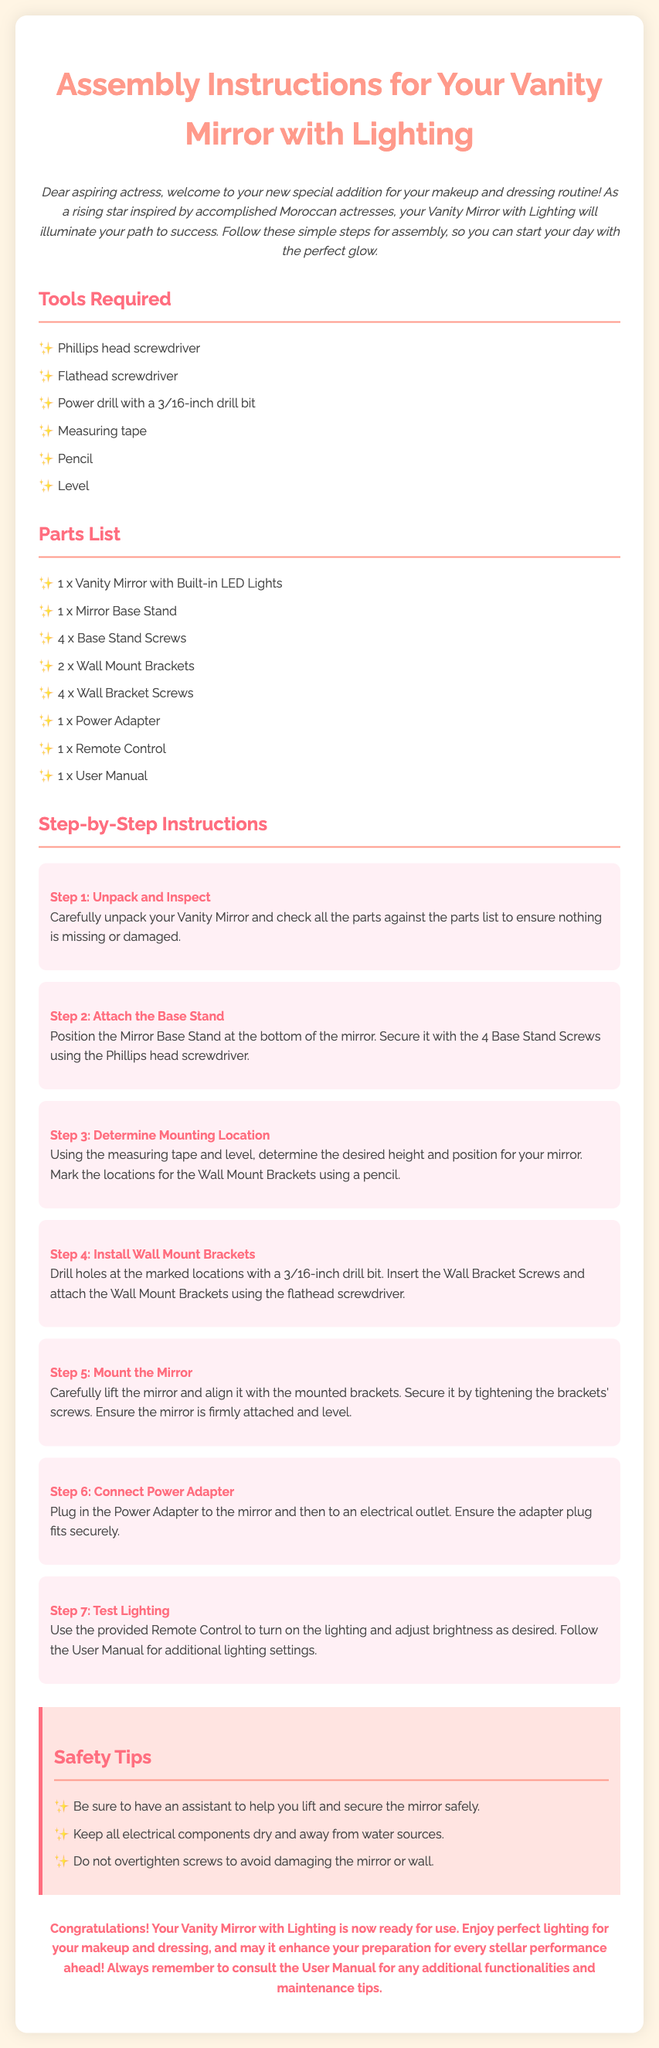What tools are required? The document lists the tools needed for assembly, which include a Phillips head screwdriver, flathead screwdriver, power drill, measuring tape, pencil, and level.
Answer: Phillips head screwdriver, flathead screwdriver, power drill, measuring tape, pencil, level How many base stand screws are included? The parts list specifies that there are 4 base stand screws included with the vanity mirror.
Answer: 4 What is the first step in the assembly process? The first step outlined in the instructions is to unpack and inspect the vanity mirror to ensure all parts are accounted for.
Answer: Unpack and Inspect What is the role of the remote control? In the assembly instructions, the remote control is utilized to turn on the lighting and adjust brightness settings as per user preference.
Answer: Turn on lighting and adjust brightness What safety tip is given for lifting the mirror? The document advises to have an assistant help lift and secure the mirror safely during assembly.
Answer: Have an assistant What should you do after mounting the mirror? After mounting the mirror, the next step is to connect the power adapter to the mirror and an electrical outlet.
Answer: Connect Power Adapter Why is it important to consult the user manual? The user manual is crucial for understanding additional functionalities and maintenance tips for the vanity mirror.
Answer: Additional functionalities and maintenance tips How many steps are included in the assembly instructions? The document outlines a total of 7 steps for assembling the vanity mirror with lighting.
Answer: 7 